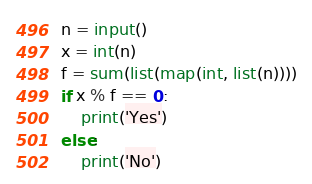Convert code to text. <code><loc_0><loc_0><loc_500><loc_500><_Python_>n = input()
x = int(n)
f = sum(list(map(int, list(n))))
if x % f == 0:
    print('Yes')
else:
    print('No')</code> 